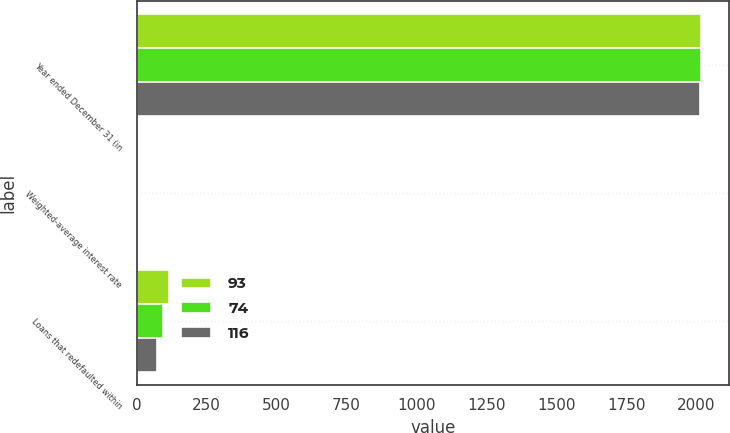Convert chart. <chart><loc_0><loc_0><loc_500><loc_500><stacked_bar_chart><ecel><fcel>Year ended December 31 (in<fcel>Weighted-average interest rate<fcel>Loans that redefaulted within<nl><fcel>93<fcel>2018<fcel>5.16<fcel>116<nl><fcel>74<fcel>2017<fcel>4.88<fcel>93<nl><fcel>116<fcel>2016<fcel>4.76<fcel>74<nl></chart> 